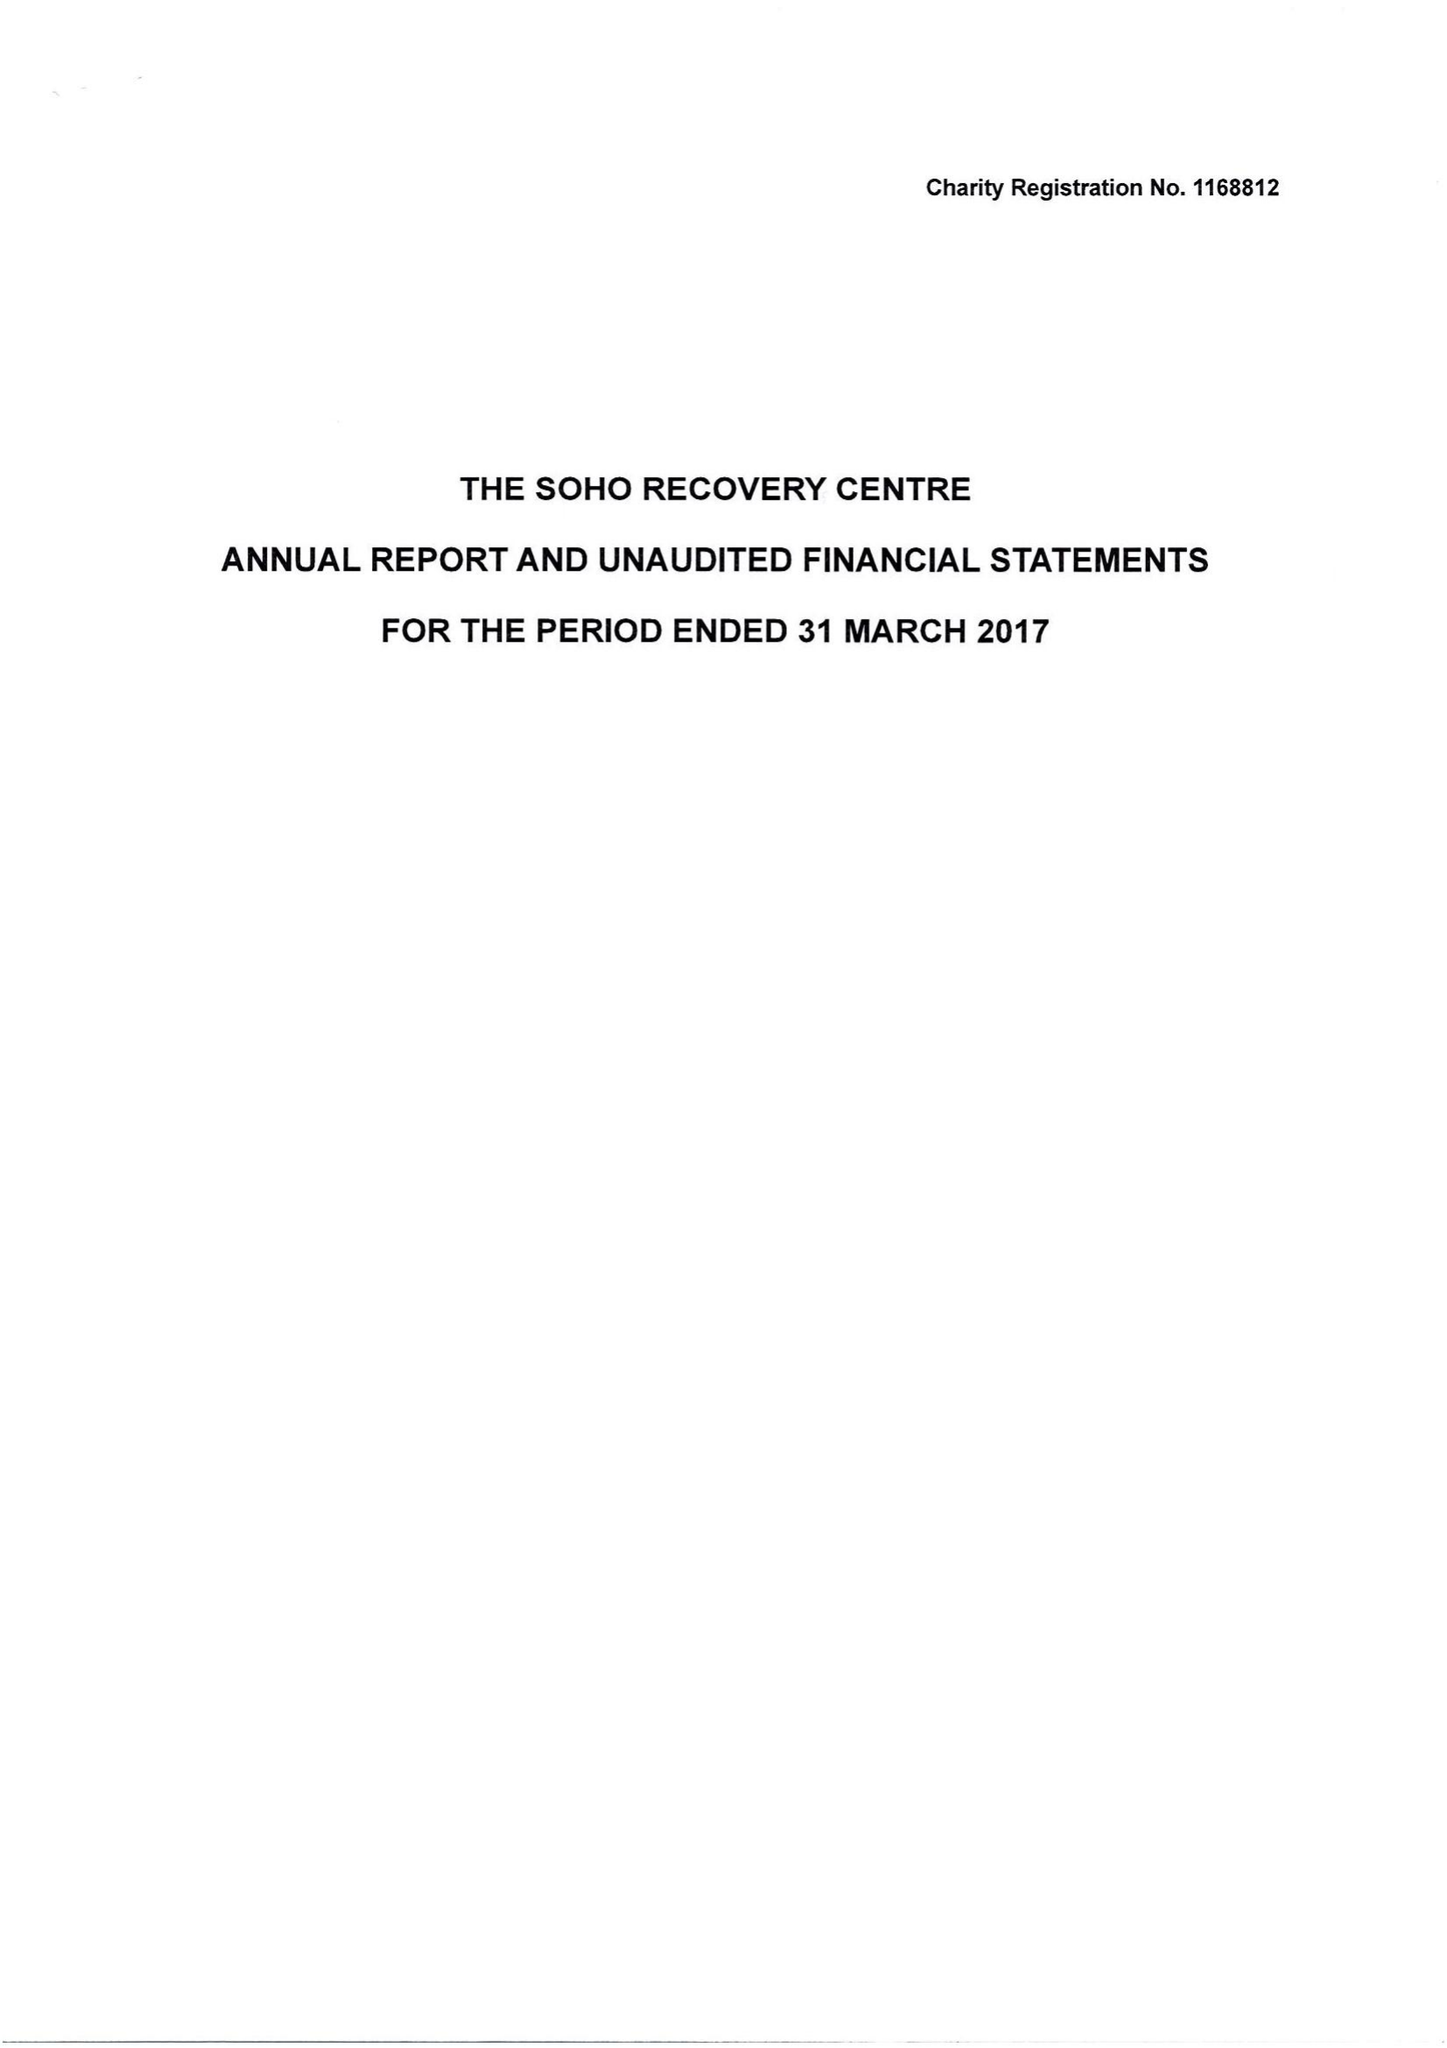What is the value for the address__street_line?
Answer the question using a single word or phrase. 123 CHARING CROSS ROAD 